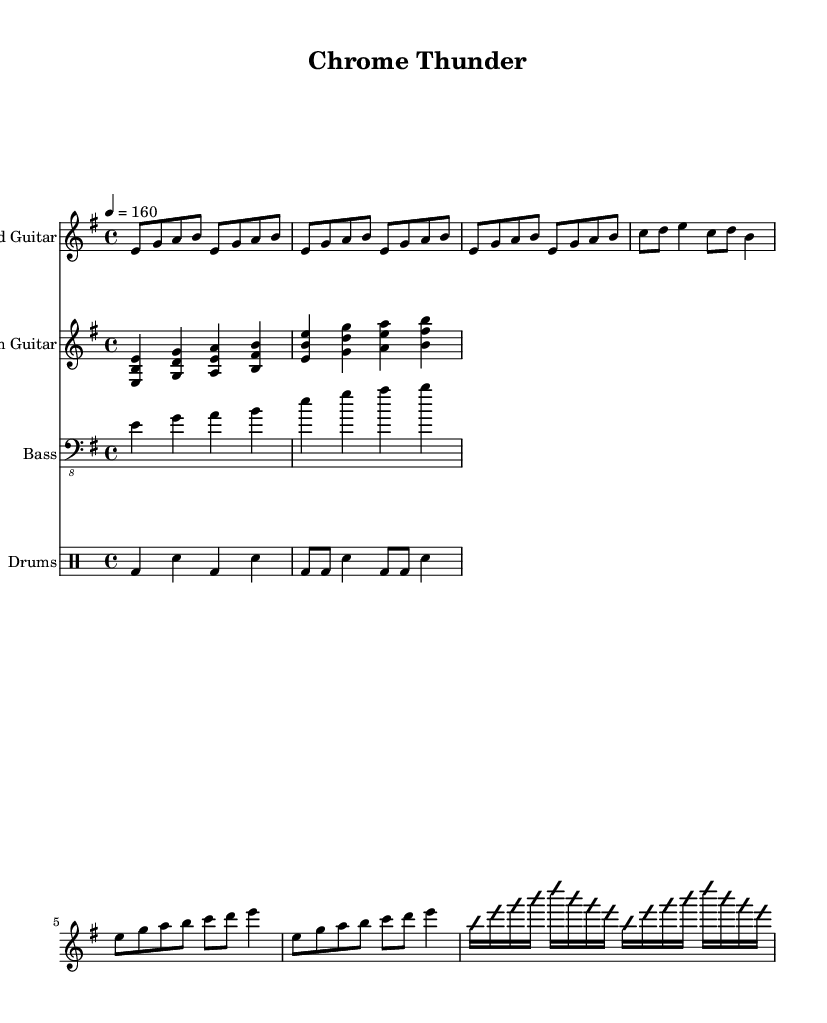What is the key signature of this music? The key signature indicated is E minor, which has one sharp (F#). This can be deduced by looking at the key signature markings at the beginning of the score.
Answer: E minor What is the time signature of this music? The time signature is 4/4, as shown at the beginning of the score. This means there are four beats in each measure and a quarter note receives one beat.
Answer: 4/4 What is the tempo marking for this piece? The tempo marking at the beginning indicates a speed of 160 beats per minute, which is common for fast-paced metal music. It is noted just above the staff with the tempo notation.
Answer: 160 What is the instrument name for the first staff? The first staff is labeled "Lead Guitar," which identifies the part that will be played on this staff. This can be seen directly above the notes in the staff.
Answer: Lead Guitar How many measures are in the verse section? The verse section consists of four measures, which can be counted by looking at the rhythmic groupings in that section. The verse part explicitly displays the notes in four distinct measures.
Answer: Four What type of rhythmic pattern is used in the drum part during the verse? The drum part during the verse primarily uses bass drum and snare hits in an alternating pattern, which is a common feature in heavy metal drumming. This can be confirmed by analyzing the drum notation in the score.
Answer: Alternating bass and snare What is the pattern of chords in the chorus section? The chorus section uses a simple progression of triads, with each chord played as a block triad in a steady rhythm, characteristic of rhythm guitar in metal. This can be seen in the notation where the chords are stacked vertically, indicating their simultaneous play.
Answer: Triads 